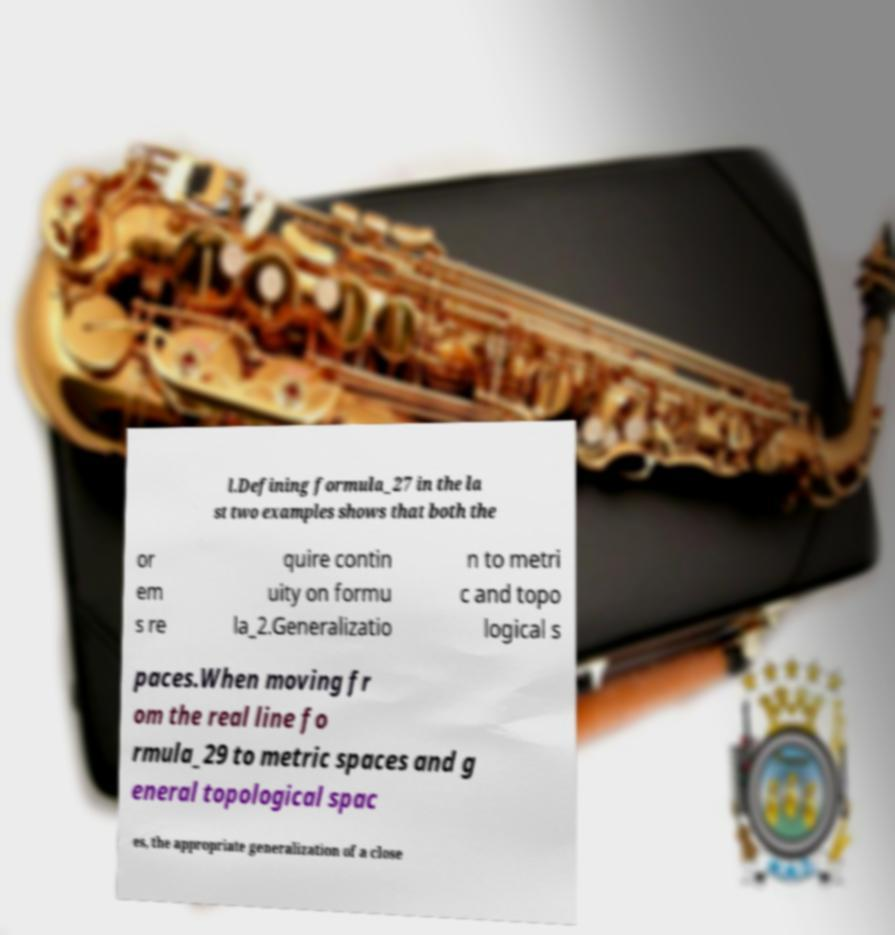Can you read and provide the text displayed in the image?This photo seems to have some interesting text. Can you extract and type it out for me? l.Defining formula_27 in the la st two examples shows that both the or em s re quire contin uity on formu la_2.Generalizatio n to metri c and topo logical s paces.When moving fr om the real line fo rmula_29 to metric spaces and g eneral topological spac es, the appropriate generalization of a close 